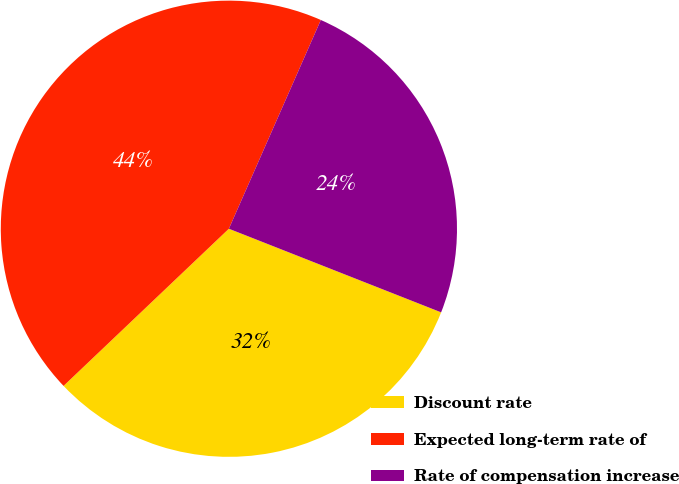Convert chart to OTSL. <chart><loc_0><loc_0><loc_500><loc_500><pie_chart><fcel>Discount rate<fcel>Expected long-term rate of<fcel>Rate of compensation increase<nl><fcel>31.93%<fcel>43.7%<fcel>24.37%<nl></chart> 